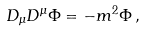<formula> <loc_0><loc_0><loc_500><loc_500>D _ { \mu } D ^ { \mu } \Phi = - m ^ { 2 } \Phi \, ,</formula> 